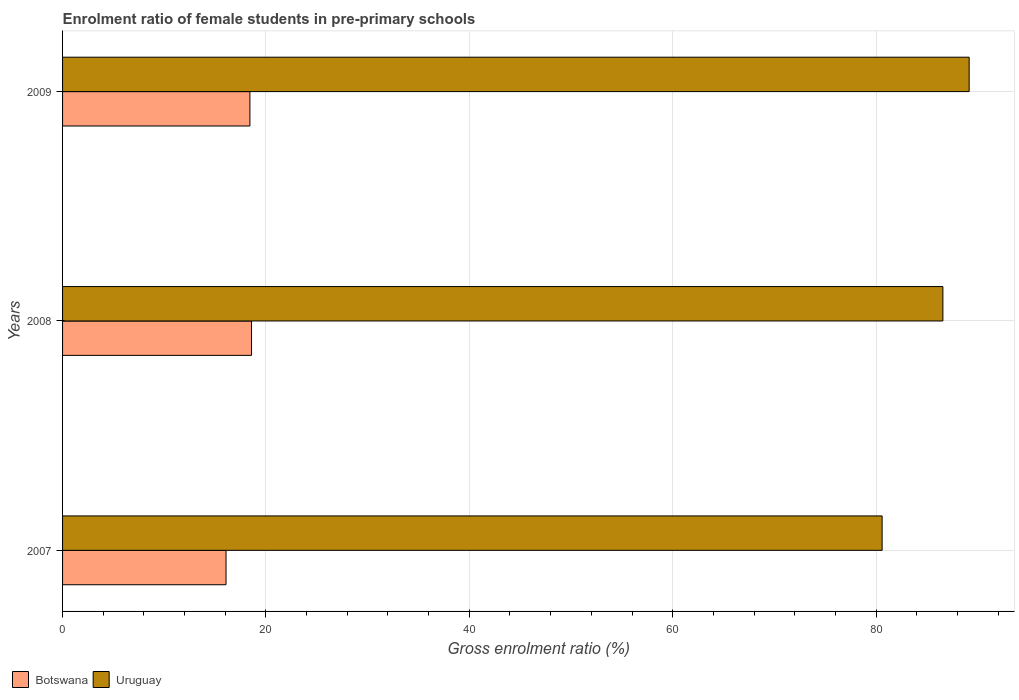Are the number of bars on each tick of the Y-axis equal?
Your response must be concise. Yes. How many bars are there on the 2nd tick from the top?
Your answer should be very brief. 2. How many bars are there on the 3rd tick from the bottom?
Provide a succinct answer. 2. What is the label of the 2nd group of bars from the top?
Provide a succinct answer. 2008. In how many cases, is the number of bars for a given year not equal to the number of legend labels?
Ensure brevity in your answer.  0. What is the enrolment ratio of female students in pre-primary schools in Botswana in 2009?
Ensure brevity in your answer.  18.42. Across all years, what is the maximum enrolment ratio of female students in pre-primary schools in Uruguay?
Ensure brevity in your answer.  89.16. Across all years, what is the minimum enrolment ratio of female students in pre-primary schools in Botswana?
Provide a short and direct response. 16.08. In which year was the enrolment ratio of female students in pre-primary schools in Uruguay maximum?
Provide a short and direct response. 2009. What is the total enrolment ratio of female students in pre-primary schools in Botswana in the graph?
Offer a very short reply. 53.08. What is the difference between the enrolment ratio of female students in pre-primary schools in Uruguay in 2008 and that in 2009?
Provide a succinct answer. -2.58. What is the difference between the enrolment ratio of female students in pre-primary schools in Uruguay in 2009 and the enrolment ratio of female students in pre-primary schools in Botswana in 2007?
Make the answer very short. 73.08. What is the average enrolment ratio of female students in pre-primary schools in Uruguay per year?
Keep it short and to the point. 85.44. In the year 2007, what is the difference between the enrolment ratio of female students in pre-primary schools in Botswana and enrolment ratio of female students in pre-primary schools in Uruguay?
Your answer should be compact. -64.52. In how many years, is the enrolment ratio of female students in pre-primary schools in Botswana greater than 84 %?
Make the answer very short. 0. What is the ratio of the enrolment ratio of female students in pre-primary schools in Uruguay in 2008 to that in 2009?
Your response must be concise. 0.97. Is the enrolment ratio of female students in pre-primary schools in Botswana in 2007 less than that in 2009?
Provide a short and direct response. Yes. What is the difference between the highest and the second highest enrolment ratio of female students in pre-primary schools in Botswana?
Give a very brief answer. 0.16. What is the difference between the highest and the lowest enrolment ratio of female students in pre-primary schools in Uruguay?
Provide a short and direct response. 8.56. In how many years, is the enrolment ratio of female students in pre-primary schools in Botswana greater than the average enrolment ratio of female students in pre-primary schools in Botswana taken over all years?
Offer a terse response. 2. Is the sum of the enrolment ratio of female students in pre-primary schools in Uruguay in 2007 and 2008 greater than the maximum enrolment ratio of female students in pre-primary schools in Botswana across all years?
Offer a terse response. Yes. What does the 1st bar from the top in 2008 represents?
Provide a succinct answer. Uruguay. What does the 2nd bar from the bottom in 2008 represents?
Make the answer very short. Uruguay. Are all the bars in the graph horizontal?
Your response must be concise. Yes. How many years are there in the graph?
Offer a very short reply. 3. What is the difference between two consecutive major ticks on the X-axis?
Keep it short and to the point. 20. Are the values on the major ticks of X-axis written in scientific E-notation?
Give a very brief answer. No. Does the graph contain grids?
Make the answer very short. Yes. Where does the legend appear in the graph?
Your response must be concise. Bottom left. What is the title of the graph?
Your response must be concise. Enrolment ratio of female students in pre-primary schools. What is the Gross enrolment ratio (%) in Botswana in 2007?
Offer a very short reply. 16.08. What is the Gross enrolment ratio (%) of Uruguay in 2007?
Your answer should be compact. 80.6. What is the Gross enrolment ratio (%) of Botswana in 2008?
Offer a terse response. 18.58. What is the Gross enrolment ratio (%) in Uruguay in 2008?
Your response must be concise. 86.57. What is the Gross enrolment ratio (%) of Botswana in 2009?
Offer a terse response. 18.42. What is the Gross enrolment ratio (%) in Uruguay in 2009?
Your response must be concise. 89.16. Across all years, what is the maximum Gross enrolment ratio (%) in Botswana?
Provide a succinct answer. 18.58. Across all years, what is the maximum Gross enrolment ratio (%) of Uruguay?
Provide a succinct answer. 89.16. Across all years, what is the minimum Gross enrolment ratio (%) in Botswana?
Your response must be concise. 16.08. Across all years, what is the minimum Gross enrolment ratio (%) of Uruguay?
Keep it short and to the point. 80.6. What is the total Gross enrolment ratio (%) of Botswana in the graph?
Provide a short and direct response. 53.08. What is the total Gross enrolment ratio (%) of Uruguay in the graph?
Offer a terse response. 256.33. What is the difference between the Gross enrolment ratio (%) of Botswana in 2007 and that in 2008?
Keep it short and to the point. -2.51. What is the difference between the Gross enrolment ratio (%) in Uruguay in 2007 and that in 2008?
Your response must be concise. -5.97. What is the difference between the Gross enrolment ratio (%) in Botswana in 2007 and that in 2009?
Make the answer very short. -2.35. What is the difference between the Gross enrolment ratio (%) in Uruguay in 2007 and that in 2009?
Your response must be concise. -8.56. What is the difference between the Gross enrolment ratio (%) in Botswana in 2008 and that in 2009?
Offer a terse response. 0.16. What is the difference between the Gross enrolment ratio (%) in Uruguay in 2008 and that in 2009?
Make the answer very short. -2.58. What is the difference between the Gross enrolment ratio (%) of Botswana in 2007 and the Gross enrolment ratio (%) of Uruguay in 2008?
Make the answer very short. -70.5. What is the difference between the Gross enrolment ratio (%) of Botswana in 2007 and the Gross enrolment ratio (%) of Uruguay in 2009?
Keep it short and to the point. -73.08. What is the difference between the Gross enrolment ratio (%) of Botswana in 2008 and the Gross enrolment ratio (%) of Uruguay in 2009?
Your response must be concise. -70.57. What is the average Gross enrolment ratio (%) in Botswana per year?
Make the answer very short. 17.69. What is the average Gross enrolment ratio (%) of Uruguay per year?
Make the answer very short. 85.44. In the year 2007, what is the difference between the Gross enrolment ratio (%) of Botswana and Gross enrolment ratio (%) of Uruguay?
Your response must be concise. -64.52. In the year 2008, what is the difference between the Gross enrolment ratio (%) in Botswana and Gross enrolment ratio (%) in Uruguay?
Your response must be concise. -67.99. In the year 2009, what is the difference between the Gross enrolment ratio (%) of Botswana and Gross enrolment ratio (%) of Uruguay?
Offer a very short reply. -70.73. What is the ratio of the Gross enrolment ratio (%) in Botswana in 2007 to that in 2008?
Offer a terse response. 0.87. What is the ratio of the Gross enrolment ratio (%) in Botswana in 2007 to that in 2009?
Provide a short and direct response. 0.87. What is the ratio of the Gross enrolment ratio (%) of Uruguay in 2007 to that in 2009?
Ensure brevity in your answer.  0.9. What is the ratio of the Gross enrolment ratio (%) in Botswana in 2008 to that in 2009?
Make the answer very short. 1.01. What is the ratio of the Gross enrolment ratio (%) of Uruguay in 2008 to that in 2009?
Offer a very short reply. 0.97. What is the difference between the highest and the second highest Gross enrolment ratio (%) of Botswana?
Your answer should be very brief. 0.16. What is the difference between the highest and the second highest Gross enrolment ratio (%) of Uruguay?
Give a very brief answer. 2.58. What is the difference between the highest and the lowest Gross enrolment ratio (%) of Botswana?
Give a very brief answer. 2.51. What is the difference between the highest and the lowest Gross enrolment ratio (%) in Uruguay?
Give a very brief answer. 8.56. 